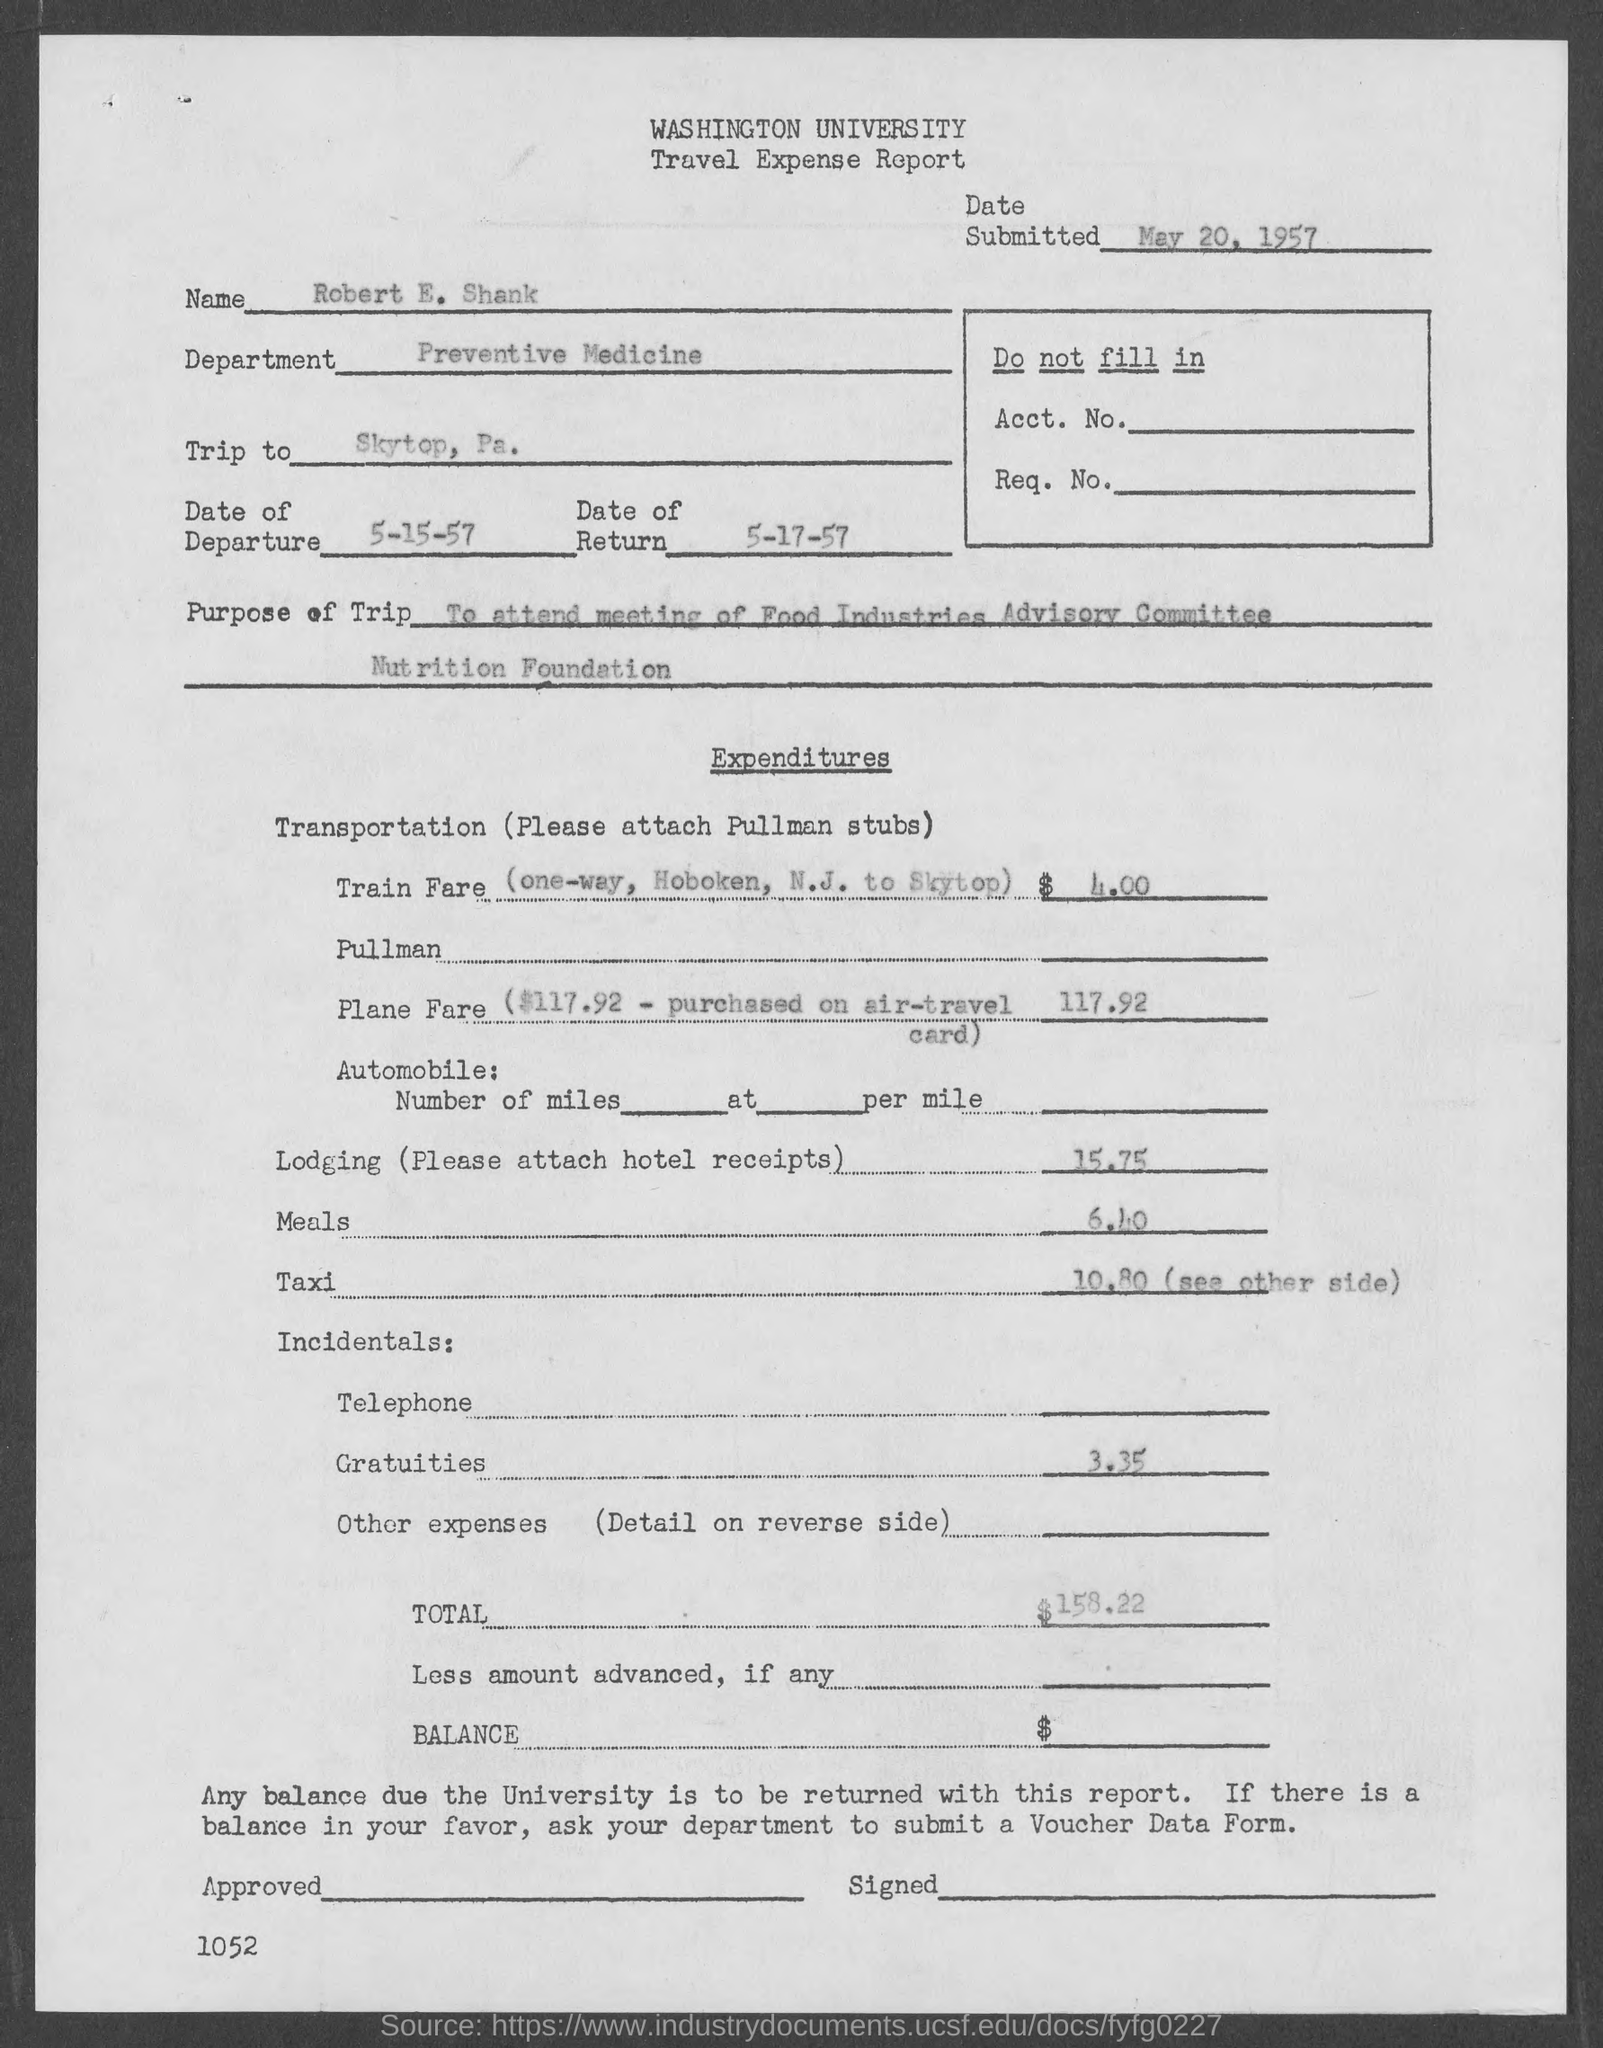Indicate a few pertinent items in this graphic. The total travel expense mentioned in the document is $158.22. The name appearing on the travel expense report is Robert E. Shank. Robert E. Shank works in the department of Preventive Medicine. The travel expense report indicates that the date of departure is May 15th, 1957. The purpose of the trip mentioned in the report is to attend the meeting of the Food Industries Advisory Committee Nutrition Foundation. 